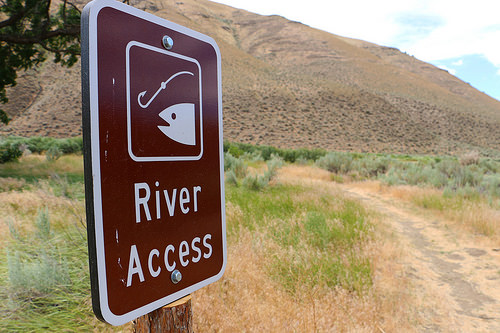<image>
Is the hill behind the fish? Yes. From this viewpoint, the hill is positioned behind the fish, with the fish partially or fully occluding the hill. 